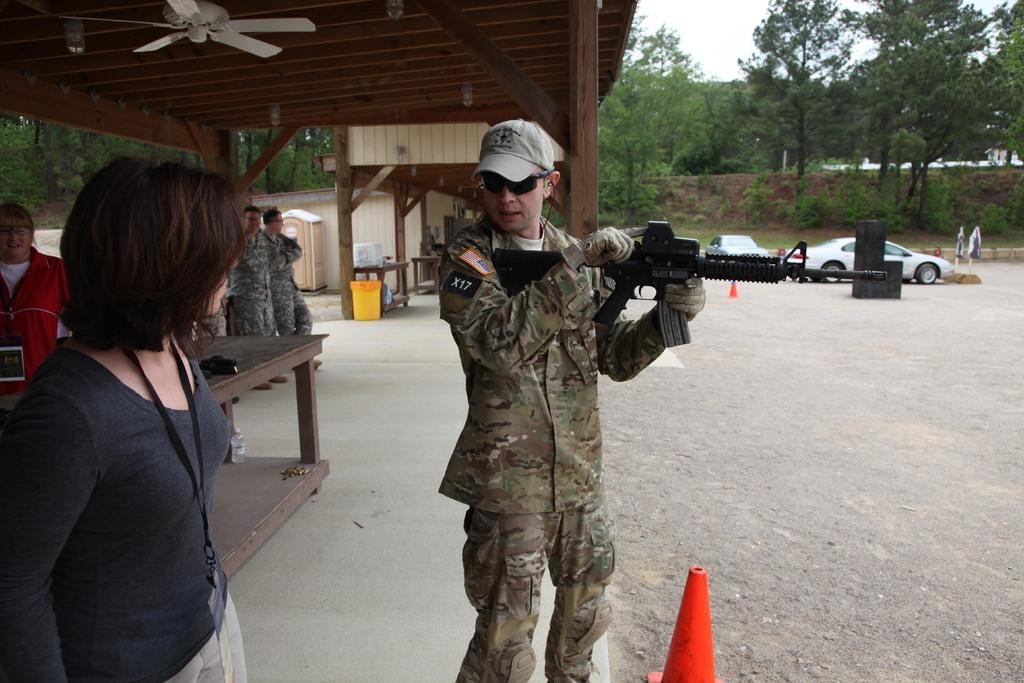Describe this image in one or two sentences. In this picture we can see two people standing on the ground and a man holding a gun with his hands. At the back of them we can see some people, tables, roof, fan, booth, walls, pillars and some objects. In the background we can see cars, traffic cones, trees, some objects and the sky. 